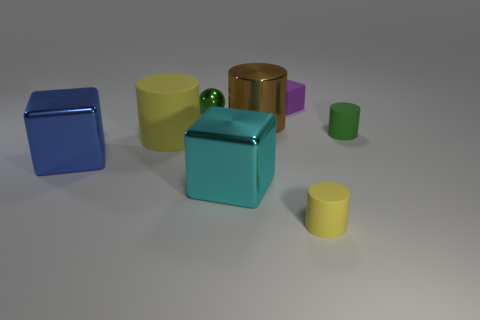Does the cyan shiny block have the same size as the block left of the small green metallic sphere?
Your response must be concise. Yes. What number of balls are brown metal objects or small green rubber things?
Offer a very short reply. 0. What number of small objects are on the left side of the tiny green matte cylinder and behind the big cyan metal block?
Provide a short and direct response. 2. What number of other things are the same color as the large matte cylinder?
Your response must be concise. 1. There is a green thing that is on the right side of the purple matte block; what is its shape?
Your answer should be very brief. Cylinder. Does the tiny green sphere have the same material as the large brown thing?
Provide a succinct answer. Yes. There is a tiny cube; what number of small matte objects are behind it?
Keep it short and to the point. 0. What shape is the matte thing behind the green object on the left side of the small purple matte thing?
Offer a terse response. Cube. Is there anything else that is the same shape as the purple rubber object?
Give a very brief answer. Yes. Is the number of blocks to the right of the shiny cylinder greater than the number of tiny red rubber blocks?
Your answer should be very brief. Yes. 